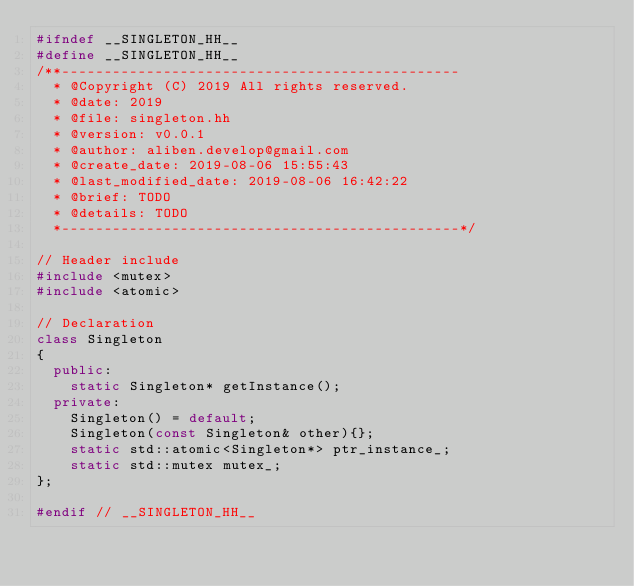<code> <loc_0><loc_0><loc_500><loc_500><_C++_>#ifndef __SINGLETON_HH__
#define __SINGLETON_HH__
/**-----------------------------------------------
  * @Copyright (C) 2019 All rights reserved.
  * @date: 2019
  * @file: singleton.hh
  * @version: v0.0.1
  * @author: aliben.develop@gmail.com
  * @create_date: 2019-08-06 15:55:43
  * @last_modified_date: 2019-08-06 16:42:22
  * @brief: TODO
  * @details: TODO
  *-----------------------------------------------*/

// Header include
#include <mutex>
#include <atomic>

// Declaration
class Singleton
{
  public:
    static Singleton* getInstance();
  private:
    Singleton() = default;
    Singleton(const Singleton& other){};
    static std::atomic<Singleton*> ptr_instance_;
    static std::mutex mutex_;
};

#endif // __SINGLETON_HH__
</code> 